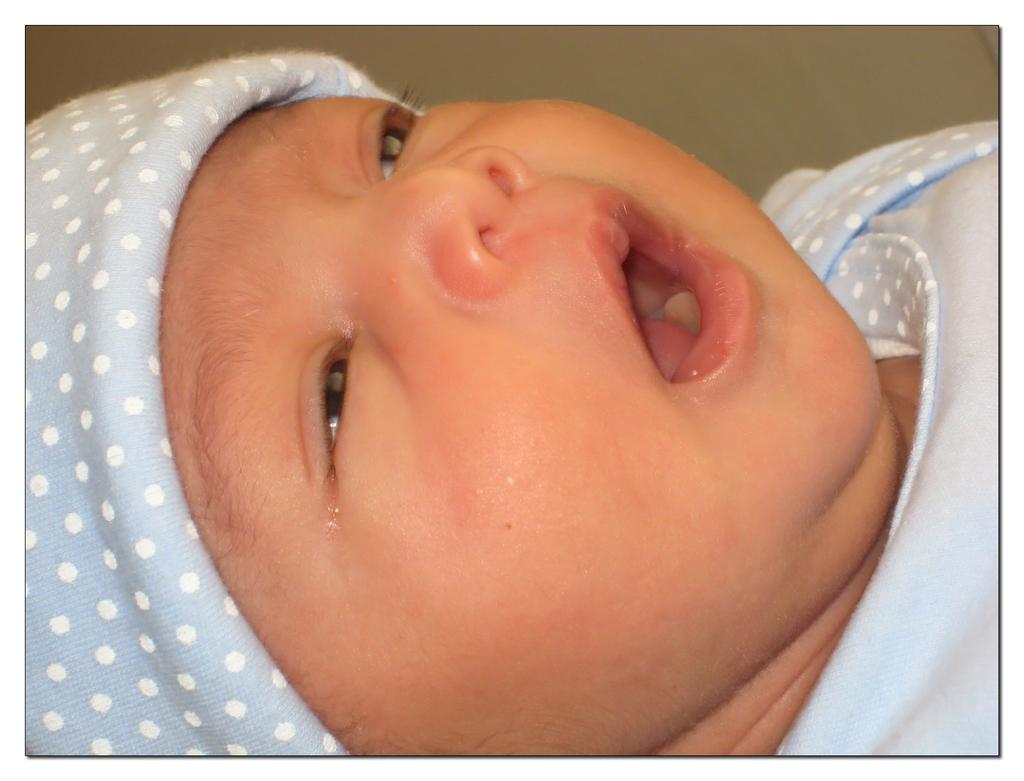What is the main subject of the picture? The main subject of the picture is a baby. What is the baby wearing in the picture? The baby is wearing a light blue dress. What is the baby doing in the picture? The baby has opened her mouth. What type of air transport can be seen in the background of the image? There is no air transport visible in the background of the image. Can you tell me how many zippers are on the baby's dress? The baby's dress does not have any zippers. 